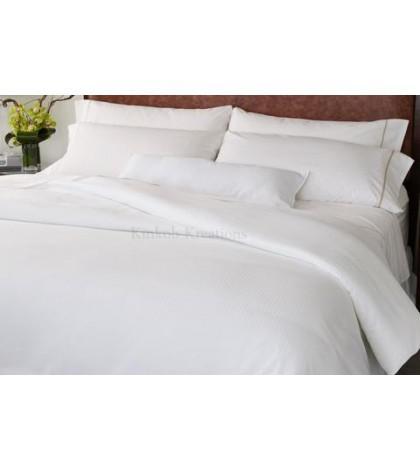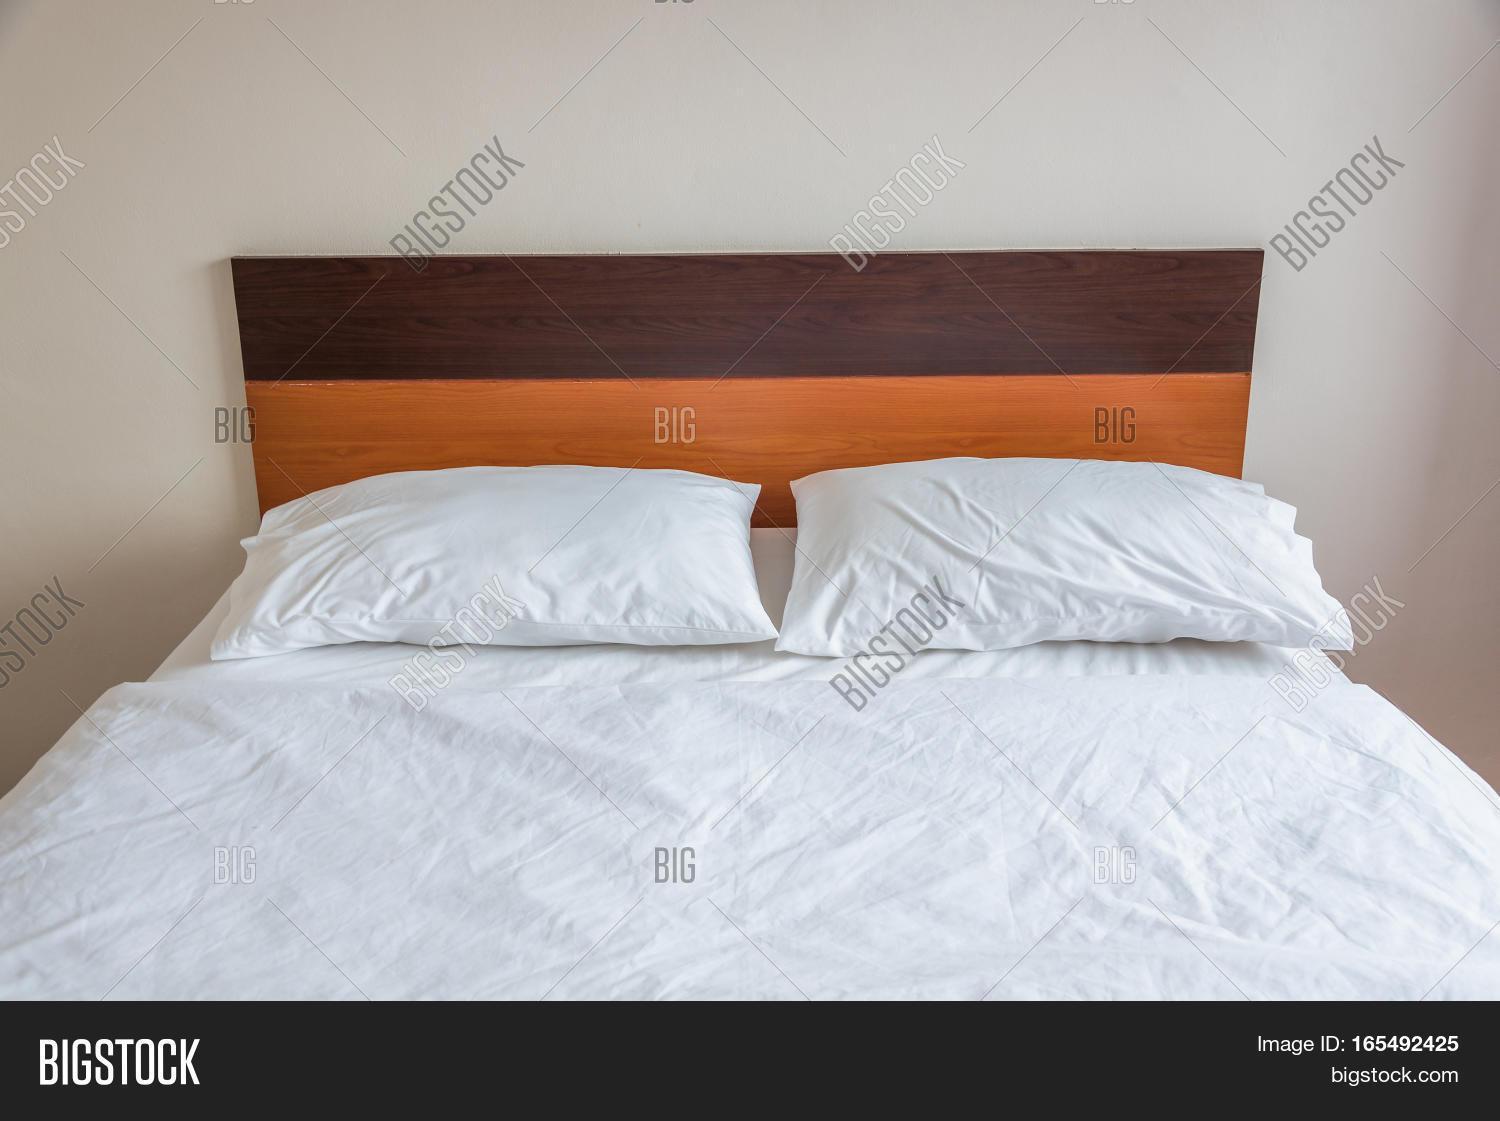The first image is the image on the left, the second image is the image on the right. For the images shown, is this caption "The left and right images both show white pillows on a bed with all white bedding." true? Answer yes or no. Yes. 